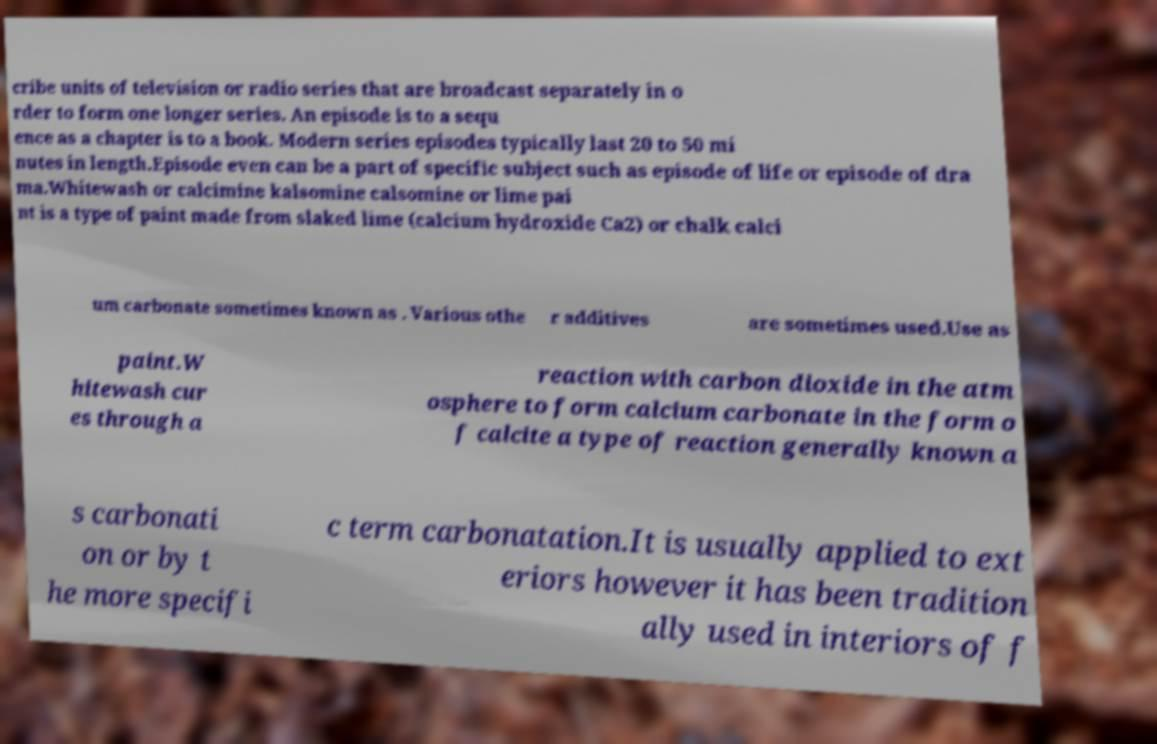I need the written content from this picture converted into text. Can you do that? cribe units of television or radio series that are broadcast separately in o rder to form one longer series. An episode is to a sequ ence as a chapter is to a book. Modern series episodes typically last 20 to 50 mi nutes in length.Episode even can be a part of specific subject such as episode of life or episode of dra ma.Whitewash or calcimine kalsomine calsomine or lime pai nt is a type of paint made from slaked lime (calcium hydroxide Ca2) or chalk calci um carbonate sometimes known as . Various othe r additives are sometimes used.Use as paint.W hitewash cur es through a reaction with carbon dioxide in the atm osphere to form calcium carbonate in the form o f calcite a type of reaction generally known a s carbonati on or by t he more specifi c term carbonatation.It is usually applied to ext eriors however it has been tradition ally used in interiors of f 